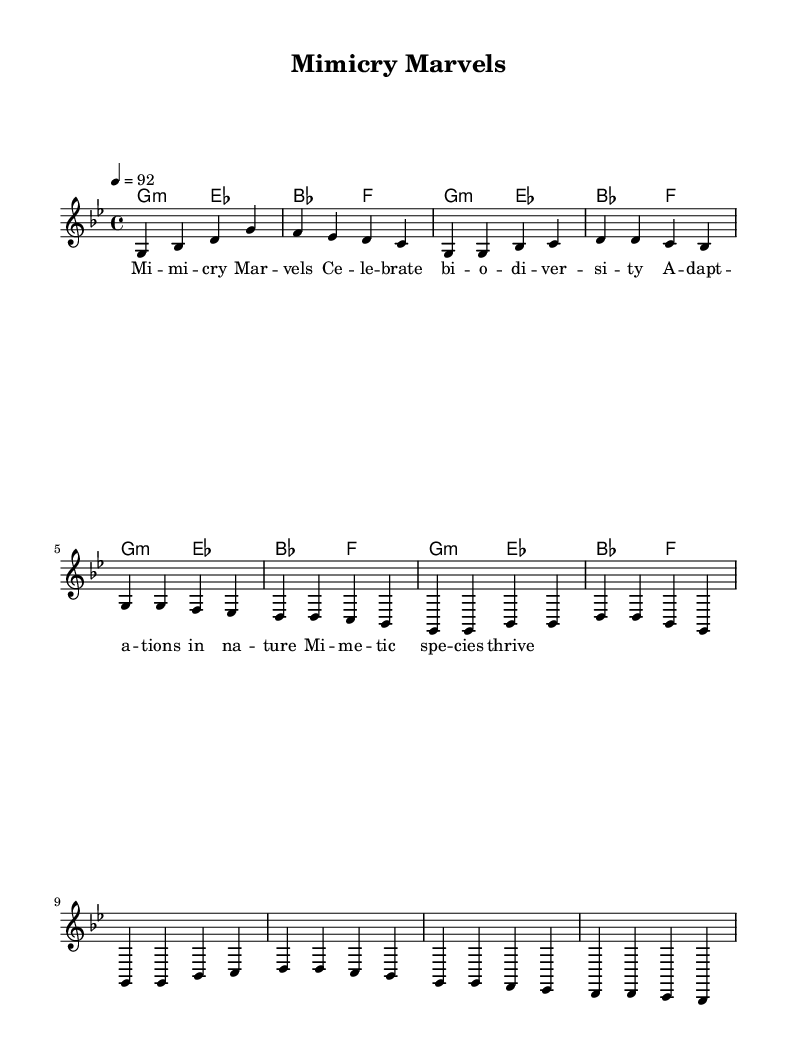What is the key signature of this music? The key signature is indicated at the beginning of the staff, showing one flat (B♭) and defining the piece as being in G minor.
Answer: G minor What is the time signature of the piece? The time signature is shown at the beginning of the staff, represented as a "4/4" time signature, meaning there are four beats in a measure.
Answer: 4/4 What is the tempo marking of the music? The tempo is specified with a marking "4 = 92," indicating that there are 92 beats per minute.
Answer: 92 How many measures are in the verse section? The verse section includes a simple melody of 8 counts divided into 2 measures, meaning there are 2 measures in this section as seen in the sheet.
Answer: 2 What is the primary theme of the lyrics provided? The lyrics mention "Mimicry Marvels" and highlight "celebrate biodiversity," indicating that the central theme is about diversity in species and adaptations in nature.
Answer: Biodiversity How many different harmonic chords are used in the harmony section? The harmonic section consists of two distinct chords, G minor and E♭ major, which are repeated, leading to a total of two separate harmonic chord types.
Answer: 2 What type of music style is this composition? The use of a steady beat, rhythmic lyrics, and the celebration of topics such as biodiversity indicate that this piece is categorized as rap music, which often integrates these elements.
Answer: Rap 